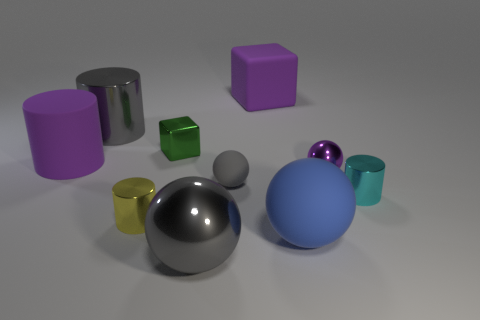There is a big gray object that is on the right side of the large gray thing that is behind the purple rubber object that is in front of the gray cylinder; what is its shape? The big gray object in question is a sphere, exhibiting a perfectly symmetrical round shape that contrasts with the various other forms around it. 